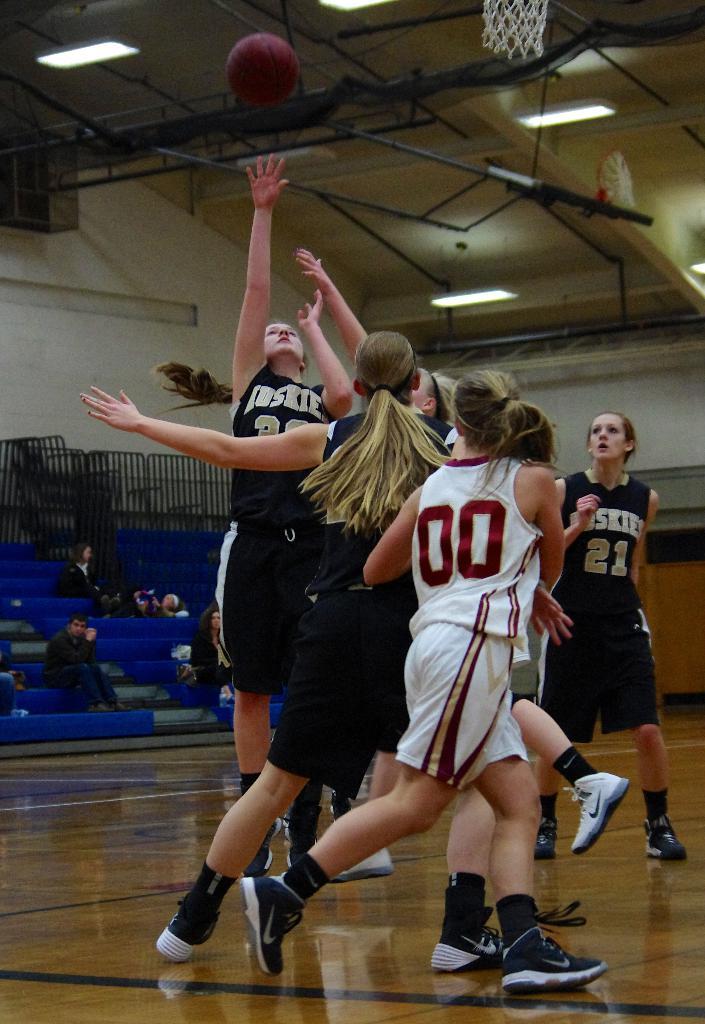Can you see the numbers on the jersey?
Give a very brief answer. Yes. 